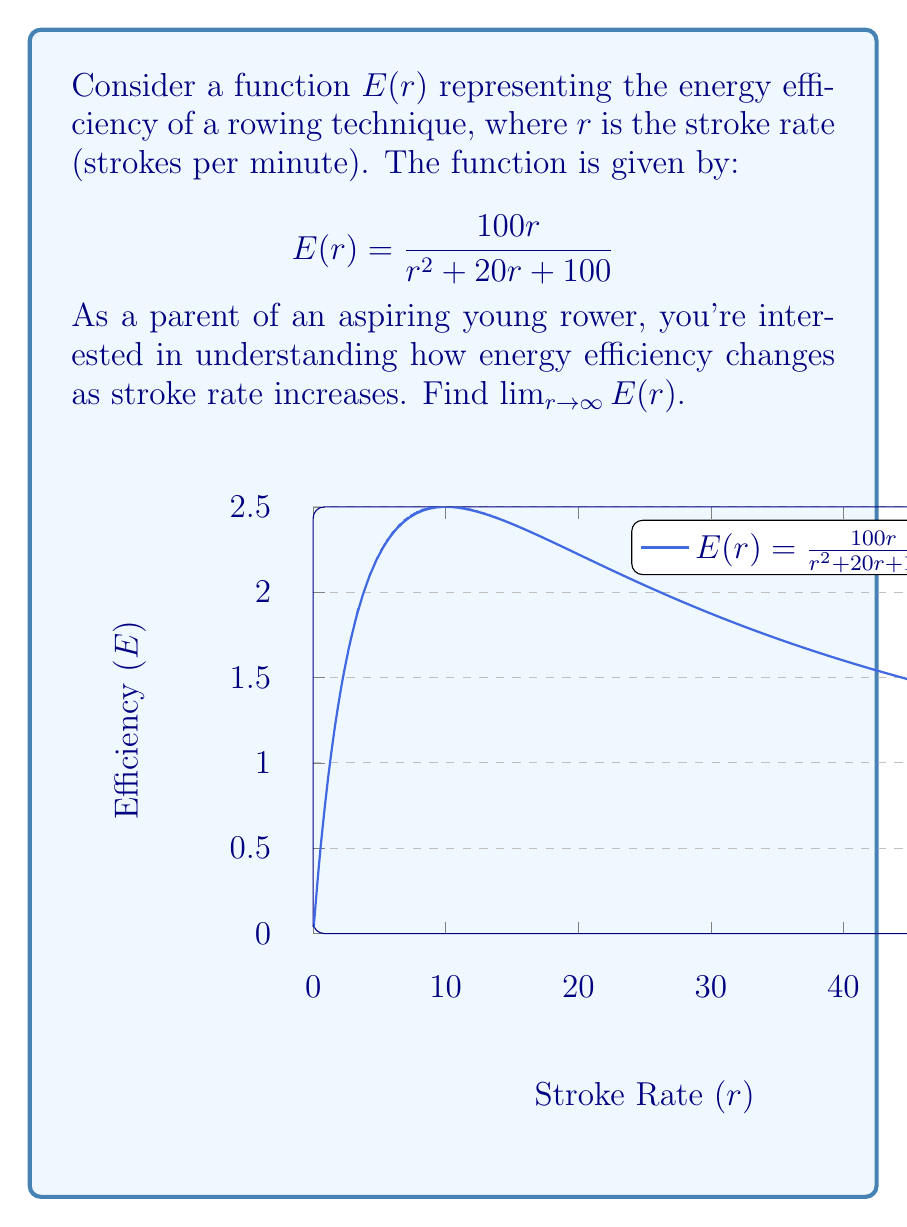Could you help me with this problem? To find the limit of $E(r)$ as $r$ approaches infinity, we'll follow these steps:

1) First, let's examine the function:
   $$E(r) = \frac{100r}{r^2 + 20r + 100}$$

2) To find the limit as $r$ approaches infinity, we need to look at the behavior of the numerator and denominator separately.

3) In the numerator, we have a linear term $100r$.
   In the denominator, we have a quadratic term $r^2 + 20r + 100$.

4) As $r$ becomes very large, the $r^2$ term in the denominator will dominate.

5) We can factor out the highest power of $r$ from both numerator and denominator:
   $$\lim_{r \to \infty} E(r) = \lim_{r \to \infty} \frac{100r}{r^2 + 20r + 100} = \lim_{r \to \infty} \frac{100 \cdot \frac{r}{r^2}}{\frac{r^2}{r^2} + \frac{20r}{r^2} + \frac{100}{r^2}}$$

6) Simplify:
   $$\lim_{r \to \infty} \frac{100 \cdot \frac{1}{r}}{1 + \frac{20}{r} + \frac{100}{r^2}}$$

7) As $r$ approaches infinity, $\frac{1}{r}$ and $\frac{1}{r^2}$ approach 0:
   $$\lim_{r \to \infty} \frac{100 \cdot 0}{1 + 0 + 0} = \frac{0}{1} = 0$$

Therefore, as the stroke rate increases indefinitely, the energy efficiency approaches 0.
Answer: 0 